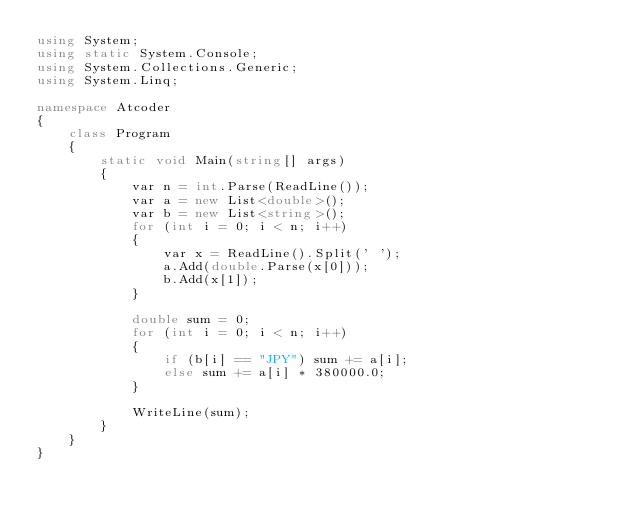<code> <loc_0><loc_0><loc_500><loc_500><_C#_>using System;
using static System.Console;
using System.Collections.Generic;
using System.Linq;

namespace Atcoder
{
    class Program
    {
        static void Main(string[] args)
        {
            var n = int.Parse(ReadLine());
            var a = new List<double>();
            var b = new List<string>();
            for (int i = 0; i < n; i++)
            {
                var x = ReadLine().Split(' ');
                a.Add(double.Parse(x[0]));
                b.Add(x[1]);
            }

            double sum = 0;
            for (int i = 0; i < n; i++)
            {
                if (b[i] == "JPY") sum += a[i];
                else sum += a[i] * 380000.0;
            }

            WriteLine(sum);
        }
    }
}

</code> 